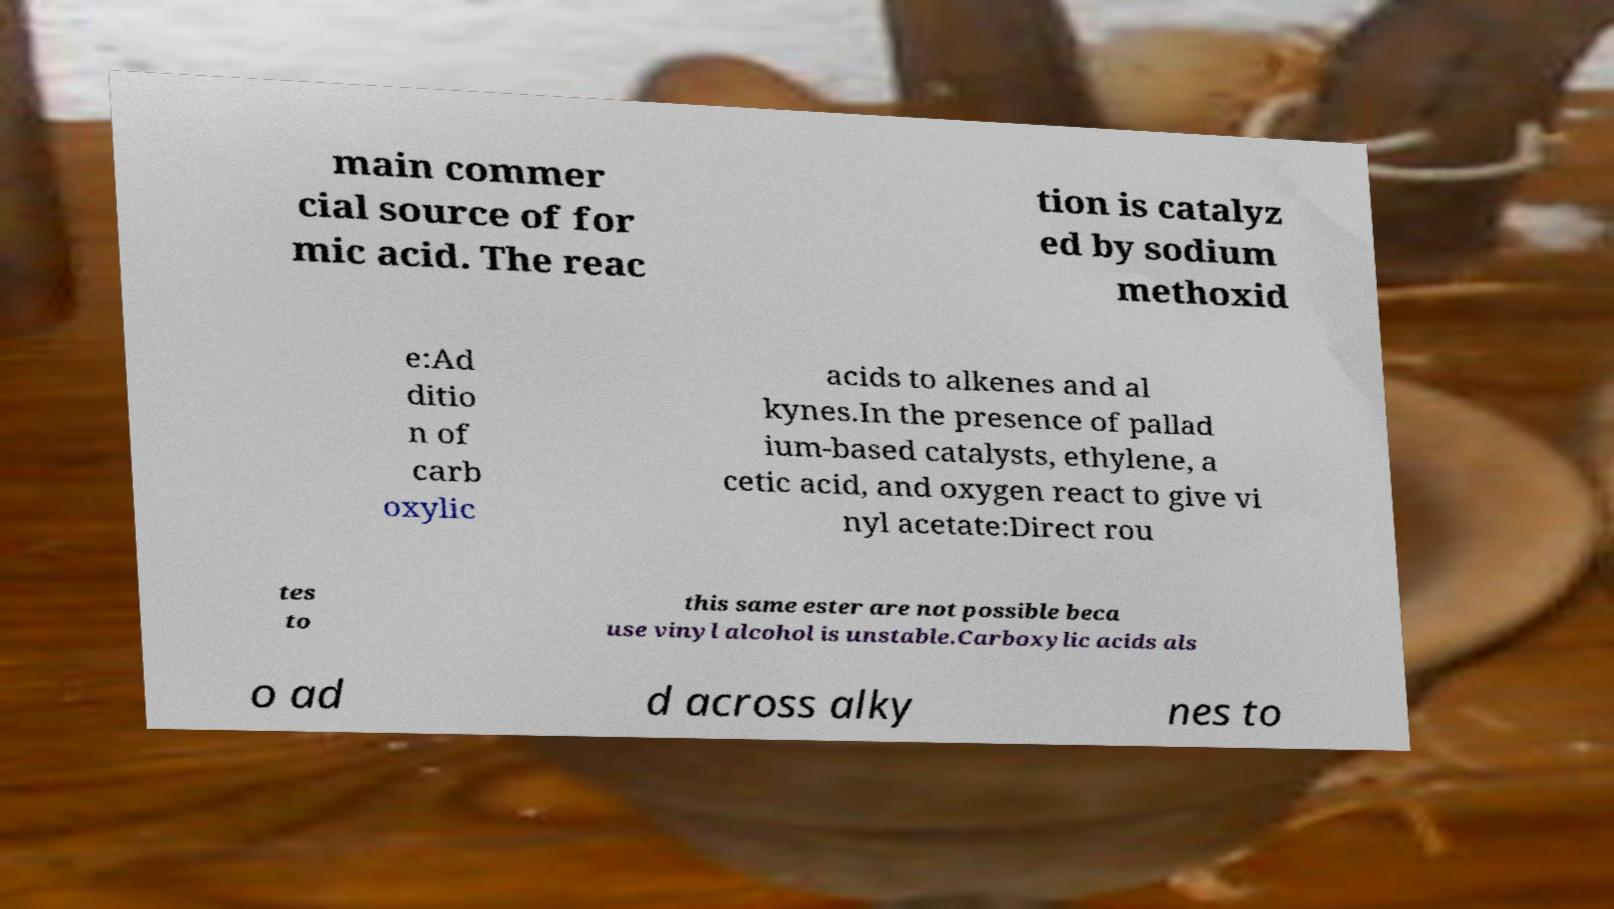For documentation purposes, I need the text within this image transcribed. Could you provide that? main commer cial source of for mic acid. The reac tion is catalyz ed by sodium methoxid e:Ad ditio n of carb oxylic acids to alkenes and al kynes.In the presence of pallad ium-based catalysts, ethylene, a cetic acid, and oxygen react to give vi nyl acetate:Direct rou tes to this same ester are not possible beca use vinyl alcohol is unstable.Carboxylic acids als o ad d across alky nes to 